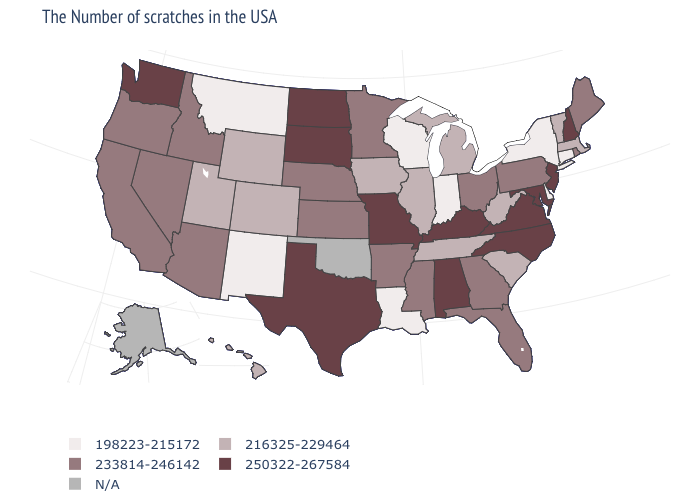Name the states that have a value in the range 198223-215172?
Answer briefly. Connecticut, New York, Delaware, Indiana, Wisconsin, Louisiana, New Mexico, Montana. Does the map have missing data?
Short answer required. Yes. Among the states that border Wyoming , which have the lowest value?
Write a very short answer. Montana. Does the first symbol in the legend represent the smallest category?
Short answer required. Yes. Name the states that have a value in the range 250322-267584?
Quick response, please. New Hampshire, New Jersey, Maryland, Virginia, North Carolina, Kentucky, Alabama, Missouri, Texas, South Dakota, North Dakota, Washington. Name the states that have a value in the range N/A?
Concise answer only. Oklahoma, Alaska. Name the states that have a value in the range 233814-246142?
Write a very short answer. Maine, Rhode Island, Pennsylvania, Ohio, Florida, Georgia, Mississippi, Arkansas, Minnesota, Kansas, Nebraska, Arizona, Idaho, Nevada, California, Oregon. Name the states that have a value in the range 250322-267584?
Keep it brief. New Hampshire, New Jersey, Maryland, Virginia, North Carolina, Kentucky, Alabama, Missouri, Texas, South Dakota, North Dakota, Washington. Name the states that have a value in the range 216325-229464?
Write a very short answer. Massachusetts, Vermont, South Carolina, West Virginia, Michigan, Tennessee, Illinois, Iowa, Wyoming, Colorado, Utah, Hawaii. Name the states that have a value in the range 216325-229464?
Concise answer only. Massachusetts, Vermont, South Carolina, West Virginia, Michigan, Tennessee, Illinois, Iowa, Wyoming, Colorado, Utah, Hawaii. Among the states that border Tennessee , which have the lowest value?
Keep it brief. Georgia, Mississippi, Arkansas. Among the states that border New Mexico , does Utah have the lowest value?
Quick response, please. Yes. What is the lowest value in the USA?
Short answer required. 198223-215172. What is the value of New Hampshire?
Write a very short answer. 250322-267584. 